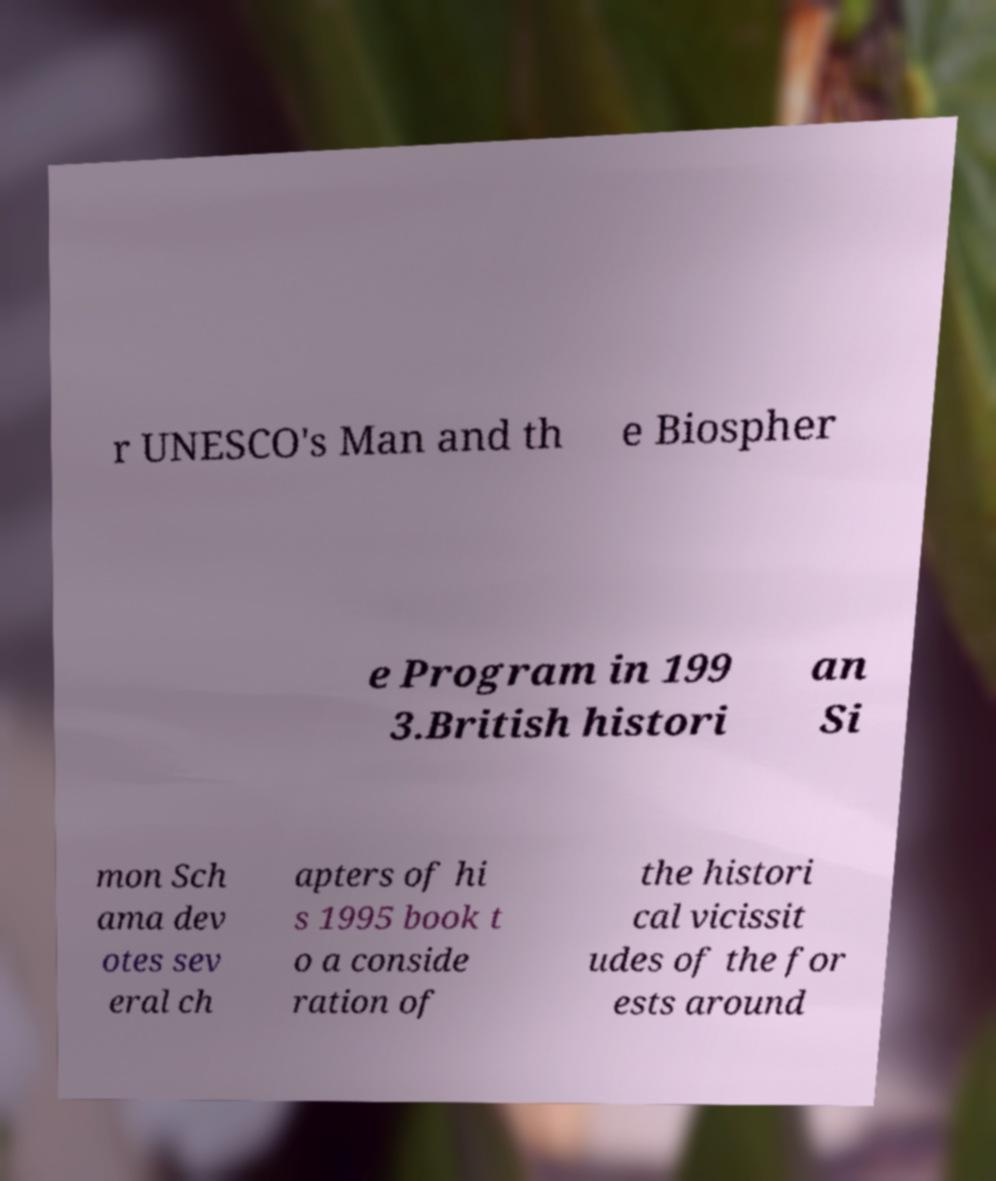I need the written content from this picture converted into text. Can you do that? r UNESCO's Man and th e Biospher e Program in 199 3.British histori an Si mon Sch ama dev otes sev eral ch apters of hi s 1995 book t o a conside ration of the histori cal vicissit udes of the for ests around 